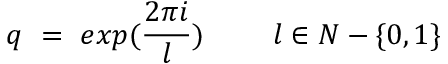Convert formula to latex. <formula><loc_0><loc_0><loc_500><loc_500>q = e x p ( \frac { 2 \pi i } { l } ) l \in N - \{ 0 , 1 \}</formula> 